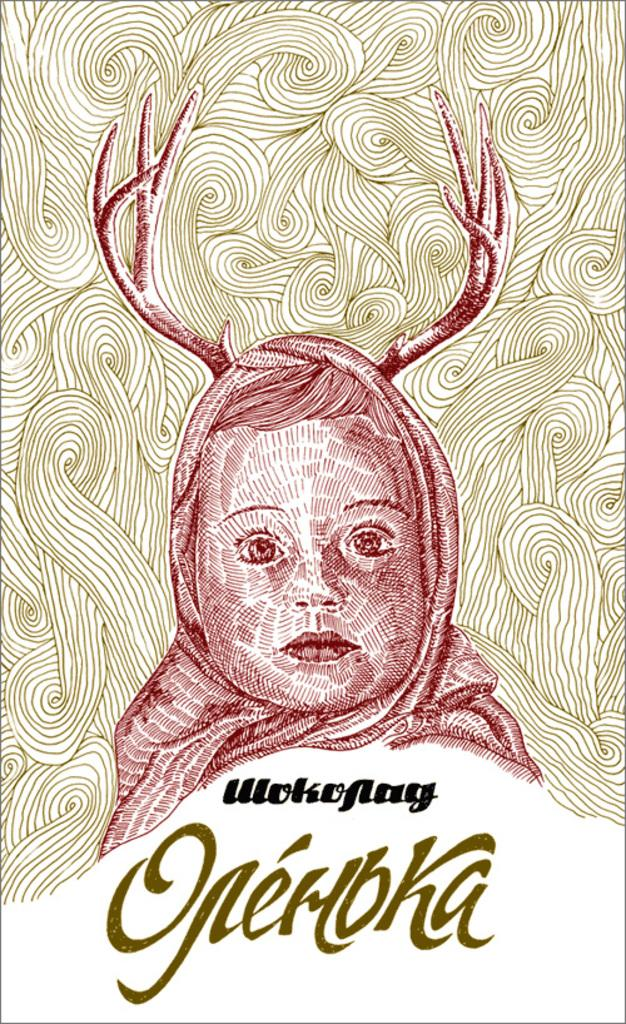What type of image is being described? The image is a sketch. What is the main subject of the sketch? There is a person's head in the center of the image. Is there any text associated with the sketch? Yes, there is text at the bottom of the image. What is the angle of the heat source in the image? There is no heat source present in the image, as it is a sketch of a person's head with text at the bottom. 